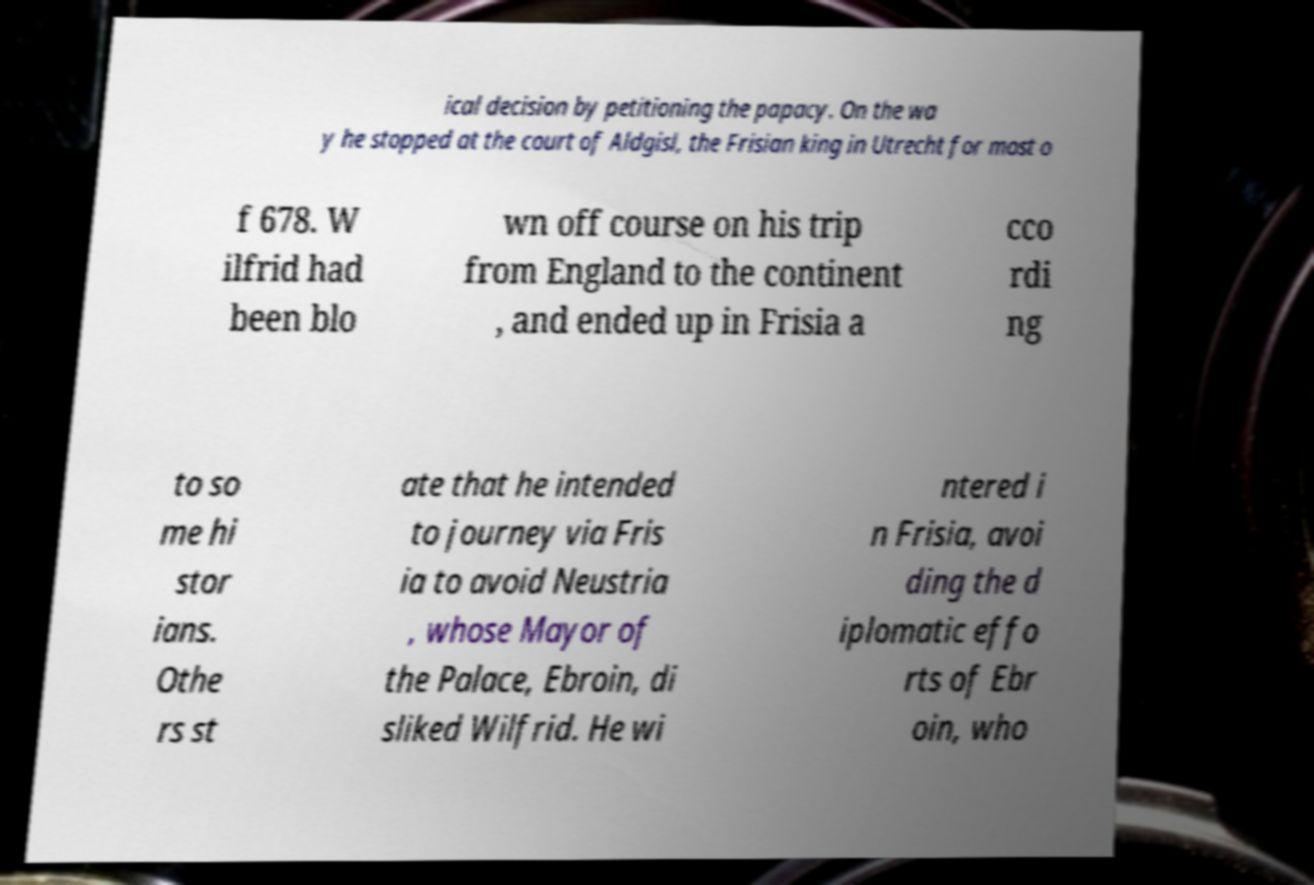Could you assist in decoding the text presented in this image and type it out clearly? ical decision by petitioning the papacy. On the wa y he stopped at the court of Aldgisl, the Frisian king in Utrecht for most o f 678. W ilfrid had been blo wn off course on his trip from England to the continent , and ended up in Frisia a cco rdi ng to so me hi stor ians. Othe rs st ate that he intended to journey via Fris ia to avoid Neustria , whose Mayor of the Palace, Ebroin, di sliked Wilfrid. He wi ntered i n Frisia, avoi ding the d iplomatic effo rts of Ebr oin, who 